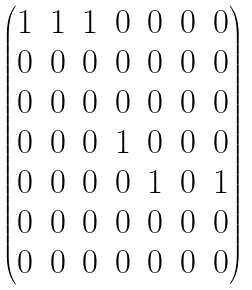<formula> <loc_0><loc_0><loc_500><loc_500>\begin{pmatrix} 1 & 1 & 1 & 0 & 0 & 0 & 0 \\ 0 & 0 & 0 & 0 & 0 & 0 & 0 \\ 0 & 0 & 0 & 0 & 0 & 0 & 0 \\ 0 & 0 & 0 & 1 & 0 & 0 & 0 \\ 0 & 0 & 0 & 0 & 1 & 0 & 1 \\ 0 & 0 & 0 & 0 & 0 & 0 & 0 \\ 0 & 0 & 0 & 0 & 0 & 0 & 0 \end{pmatrix}</formula> 